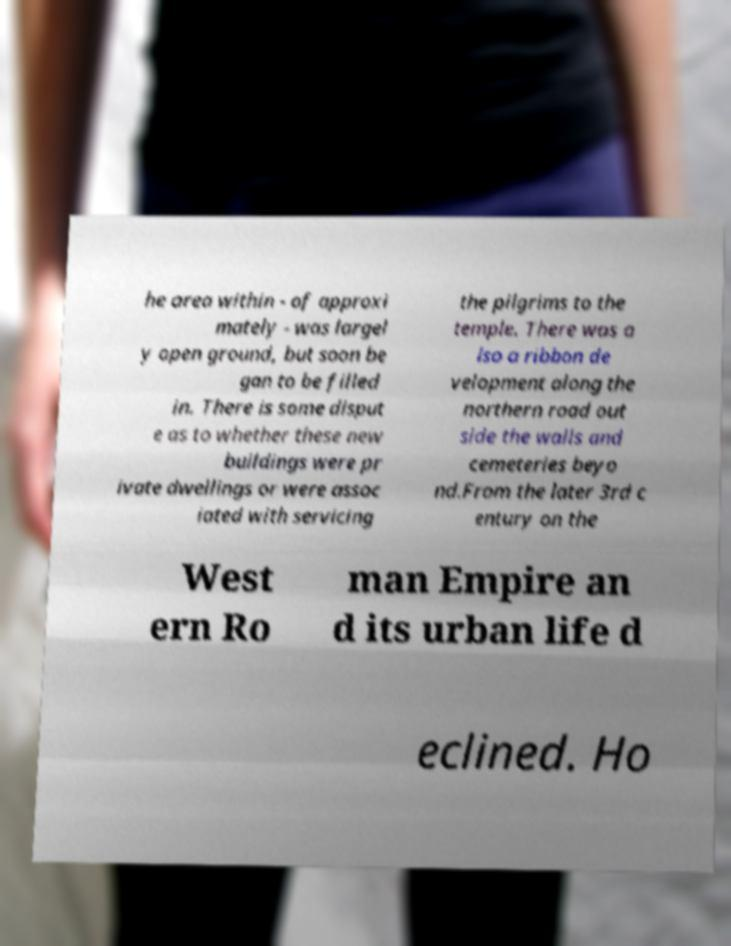Could you extract and type out the text from this image? he area within - of approxi mately - was largel y open ground, but soon be gan to be filled in. There is some disput e as to whether these new buildings were pr ivate dwellings or were assoc iated with servicing the pilgrims to the temple. There was a lso a ribbon de velopment along the northern road out side the walls and cemeteries beyo nd.From the later 3rd c entury on the West ern Ro man Empire an d its urban life d eclined. Ho 